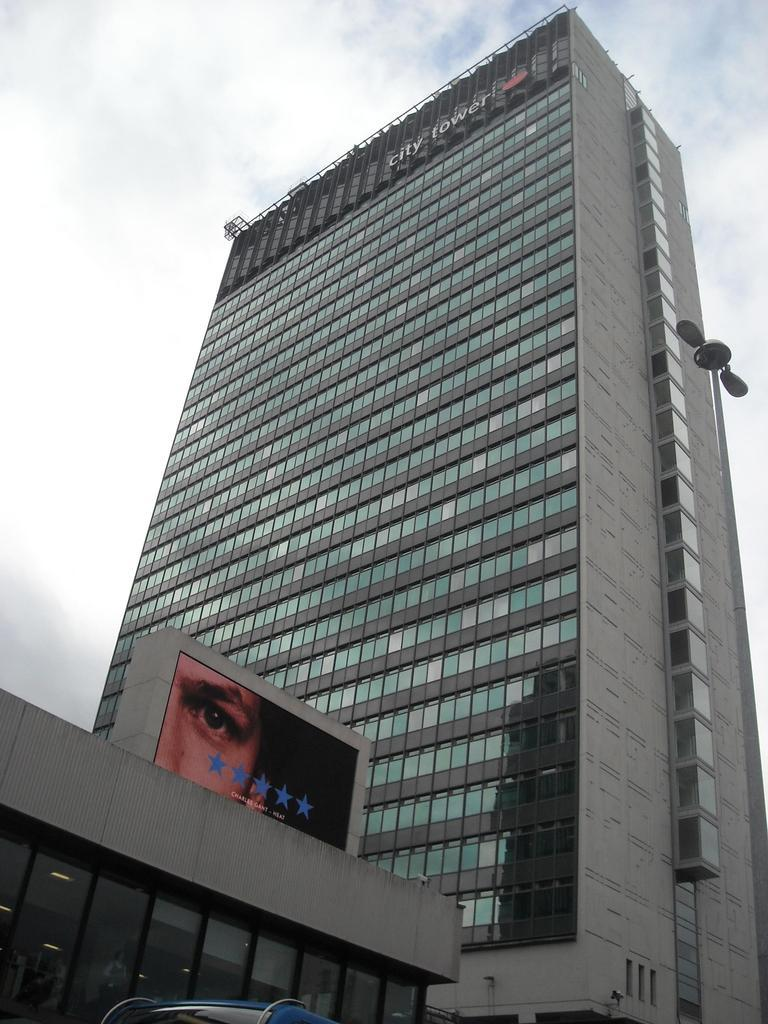What type of structures can be seen in the image? There are buildings in the image. What object is present in the image that might be used for support or signage? There is a pole in the image. What can be seen attached to the pole in the image? There are lights in the image. What part of the natural environment is visible in the image? The sky is visible in the background of the image. What type of doctor can be seen treating a turkey in the image? There is no doctor or turkey present in the image. 